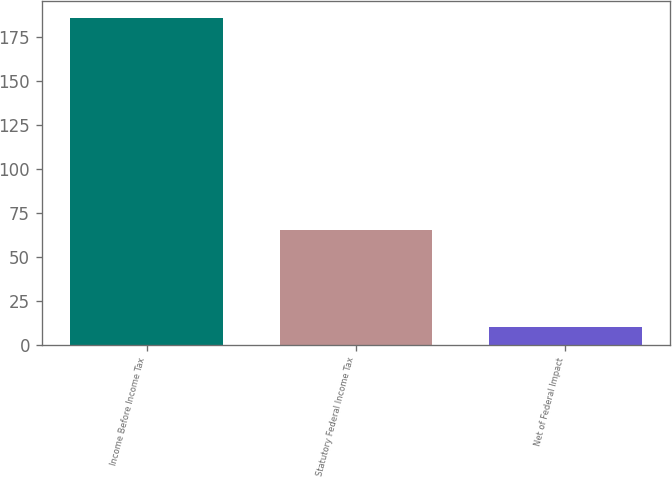<chart> <loc_0><loc_0><loc_500><loc_500><bar_chart><fcel>Income Before Income Tax<fcel>Statutory Federal Income Tax<fcel>Net of Federal Impact<nl><fcel>186.1<fcel>65.1<fcel>9.8<nl></chart> 